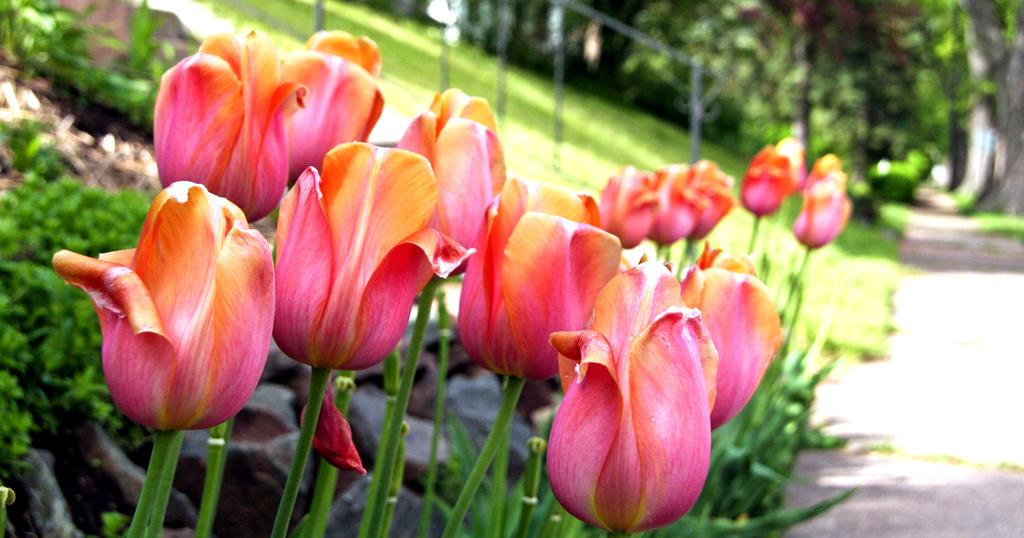What type of plants can be seen in the image? A: There are flowers in the image. How would you describe the appearance of the background in the image? The background of the image is blurred. What type of vegetation is visible in the background of the image? There is grass and trees visible in the background of the image. What other objects can be seen in the background of the image? There are poles and a road visible in the background of the image. Can you tell me how many times the flowers fold in the image? The flowers do not fold in the image; they are stationary plants. Is there a stage visible in the image? There is no stage present in the image. 